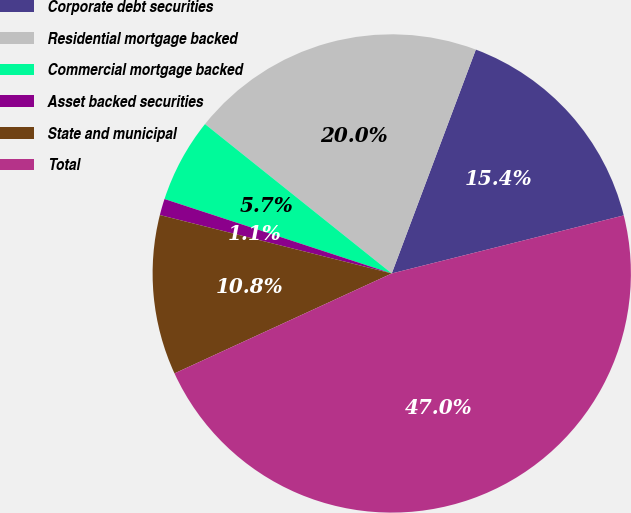<chart> <loc_0><loc_0><loc_500><loc_500><pie_chart><fcel>Corporate debt securities<fcel>Residential mortgage backed<fcel>Commercial mortgage backed<fcel>Asset backed securities<fcel>State and municipal<fcel>Total<nl><fcel>15.38%<fcel>19.98%<fcel>5.7%<fcel>1.11%<fcel>10.79%<fcel>47.04%<nl></chart> 